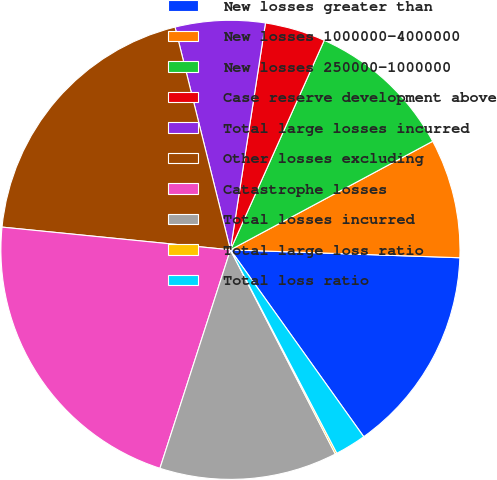Convert chart to OTSL. <chart><loc_0><loc_0><loc_500><loc_500><pie_chart><fcel>New losses greater than<fcel>New losses 1000000-4000000<fcel>New losses 250000-1000000<fcel>Case reserve development above<fcel>Total large losses incurred<fcel>Other losses excluding<fcel>Catastrophe losses<fcel>Total losses incurred<fcel>Total large loss ratio<fcel>Total loss ratio<nl><fcel>14.59%<fcel>8.39%<fcel>10.46%<fcel>4.26%<fcel>6.32%<fcel>19.54%<fcel>21.61%<fcel>12.52%<fcel>0.12%<fcel>2.19%<nl></chart> 